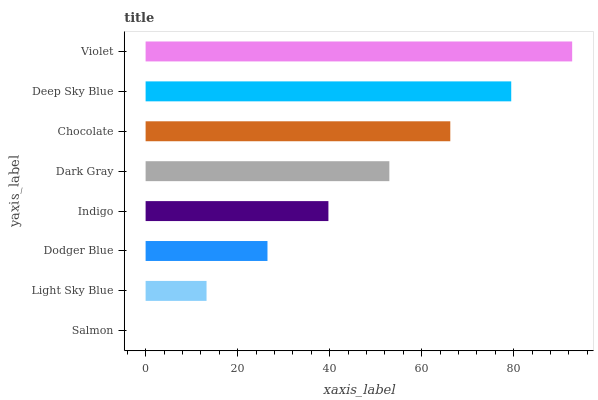Is Salmon the minimum?
Answer yes or no. Yes. Is Violet the maximum?
Answer yes or no. Yes. Is Light Sky Blue the minimum?
Answer yes or no. No. Is Light Sky Blue the maximum?
Answer yes or no. No. Is Light Sky Blue greater than Salmon?
Answer yes or no. Yes. Is Salmon less than Light Sky Blue?
Answer yes or no. Yes. Is Salmon greater than Light Sky Blue?
Answer yes or no. No. Is Light Sky Blue less than Salmon?
Answer yes or no. No. Is Dark Gray the high median?
Answer yes or no. Yes. Is Indigo the low median?
Answer yes or no. Yes. Is Violet the high median?
Answer yes or no. No. Is Dodger Blue the low median?
Answer yes or no. No. 